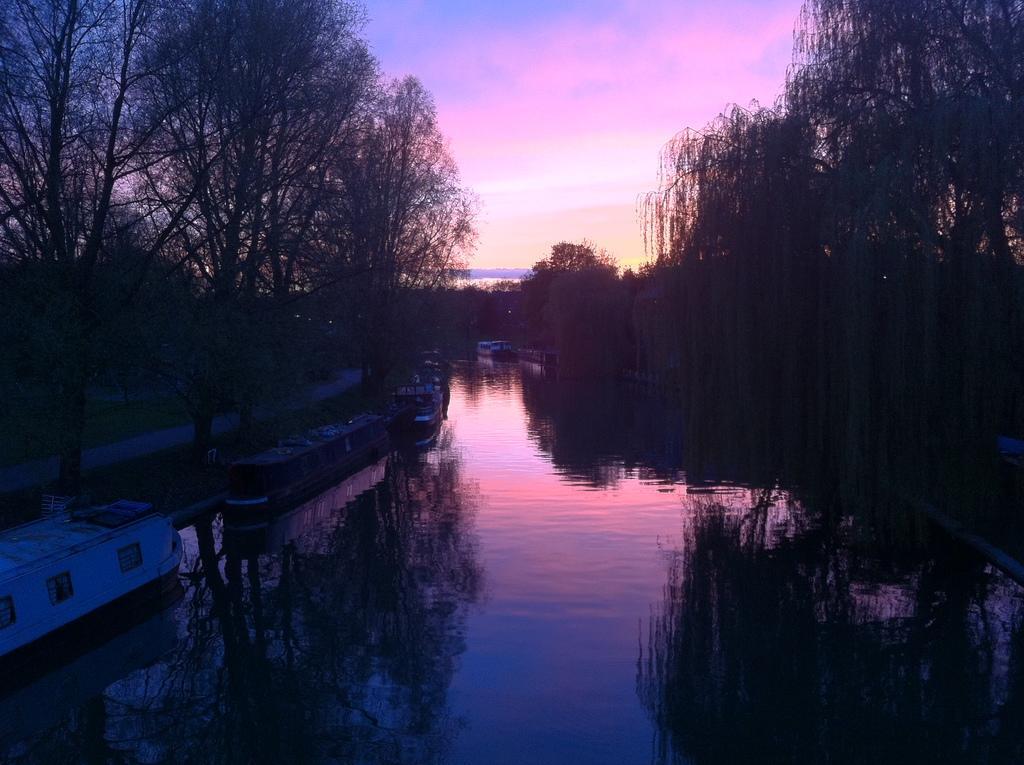Could you give a brief overview of what you see in this image? In the center of the image we can see the sky, clouds, trees, water, boats, grass and a few other objects. 